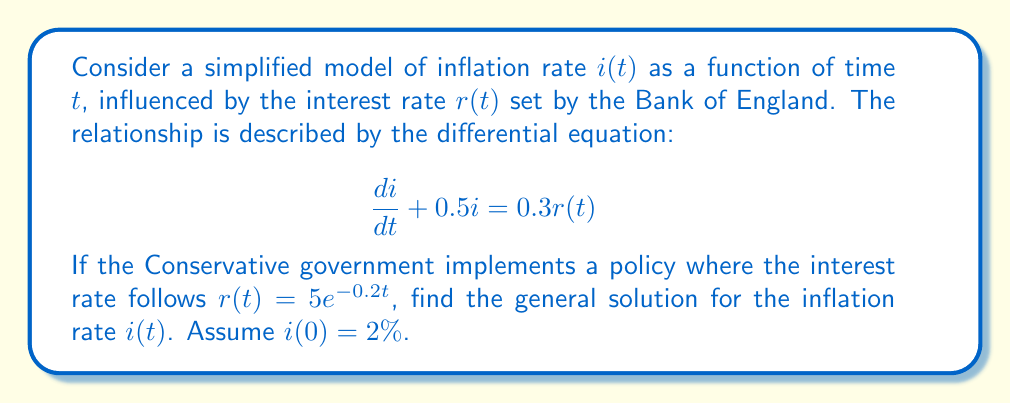What is the answer to this math problem? Let's solve this differential equation step by step:

1) We have a first-order linear differential equation:
   $$\frac{di}{dt} + 0.5i = 0.3r(t)$$
   where $r(t) = 5e^{-0.2t}$

2) Substituting $r(t)$:
   $$\frac{di}{dt} + 0.5i = 0.3(5e^{-0.2t}) = 1.5e^{-0.2t}$$

3) This is of the form $\frac{dy}{dx} + P(x)y = Q(x)$, where:
   $P(x) = 0.5$ (constant)
   $Q(x) = 1.5e^{-0.2t}$

4) The integrating factor is $\mu(t) = e^{\int P(t)dt} = e^{0.5t}$

5) Multiply both sides of the equation by $\mu(t)$:
   $$e^{0.5t}\frac{di}{dt} + 0.5e^{0.5t}i = 1.5e^{0.3t}$$

6) The left side is now the derivative of $e^{0.5t}i$:
   $$\frac{d}{dt}(e^{0.5t}i) = 1.5e^{0.3t}$$

7) Integrate both sides:
   $$e^{0.5t}i = \int 1.5e^{0.3t}dt = 1.5\int e^{0.3t}dt = 5e^{0.3t} + C$$

8) Solve for $i(t)$:
   $$i(t) = 5e^{-0.2t} + Ce^{-0.5t}$$

9) Use the initial condition $i(0) = 2\%$ to find $C$:
   $$2 = 5 + C$$
   $$C = -3$$

10) Therefore, the particular solution is:
    $$i(t) = 5e^{-0.2t} - 3e^{-0.5t}$$

This solution shows how the inflation rate changes over time under the Conservative government's interest rate policy.
Answer: $i(t) = 5e^{-0.2t} - 3e^{-0.5t}$ 